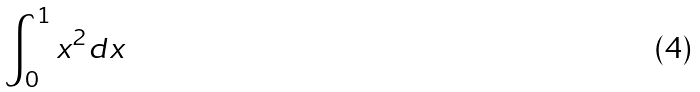Convert formula to latex. <formula><loc_0><loc_0><loc_500><loc_500>\int _ { 0 } ^ { 1 } x ^ { 2 } d x</formula> 